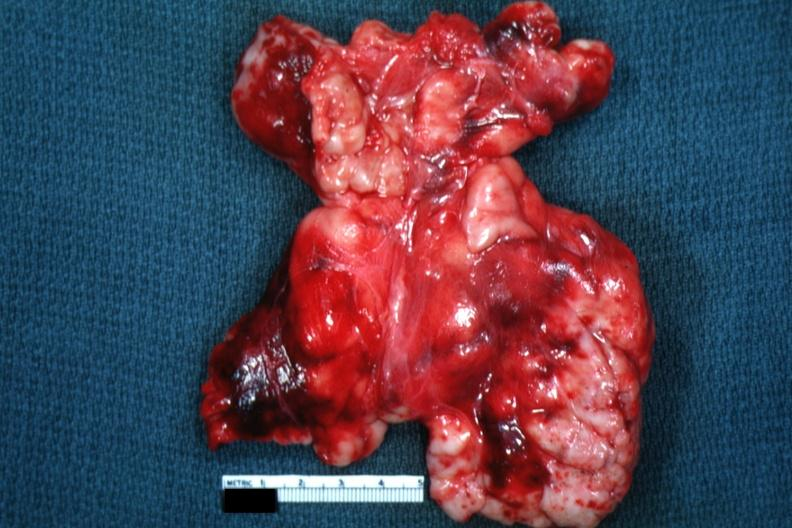what does this image appear?
Answer the question using a single word or phrase. As large mass of matted nodes like malignant lymphoma 